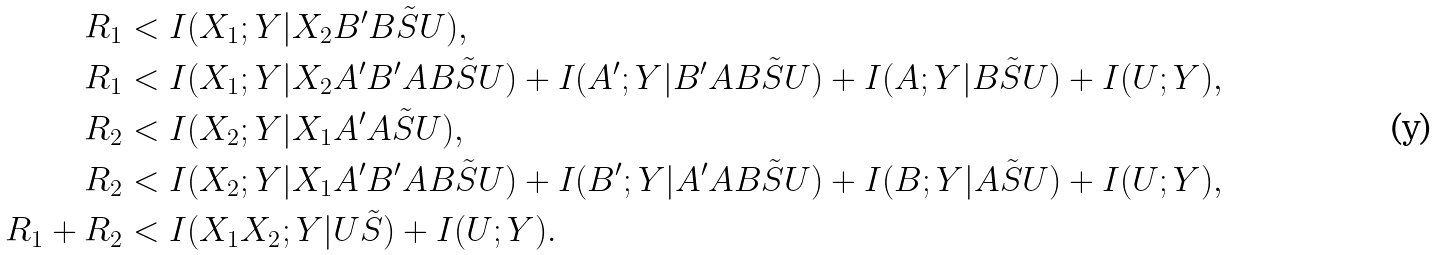Convert formula to latex. <formula><loc_0><loc_0><loc_500><loc_500>R _ { 1 } & < I ( X _ { 1 } ; Y | X _ { 2 } B ^ { \prime } B \tilde { S } U ) , \\ R _ { 1 } & < I ( X _ { 1 } ; Y | X _ { 2 } A ^ { \prime } B ^ { \prime } A B \tilde { S } U ) + I ( A ^ { \prime } ; Y | B ^ { \prime } A B \tilde { S } U ) + I ( A ; Y | B \tilde { S } U ) + I ( U ; Y ) , \\ R _ { 2 } & < I ( X _ { 2 } ; Y | X _ { 1 } A ^ { \prime } A \tilde { S } U ) , \\ R _ { 2 } & < I ( X _ { 2 } ; Y | X _ { 1 } A ^ { \prime } B ^ { \prime } A B \tilde { S } U ) + I ( B ^ { \prime } ; Y | A ^ { \prime } A B \tilde { S } U ) + I ( B ; Y | A \tilde { S } U ) + I ( U ; Y ) , \\ R _ { 1 } + R _ { 2 } & < I ( X _ { 1 } X _ { 2 } ; Y | U \tilde { S } ) + I ( U ; Y ) .</formula> 